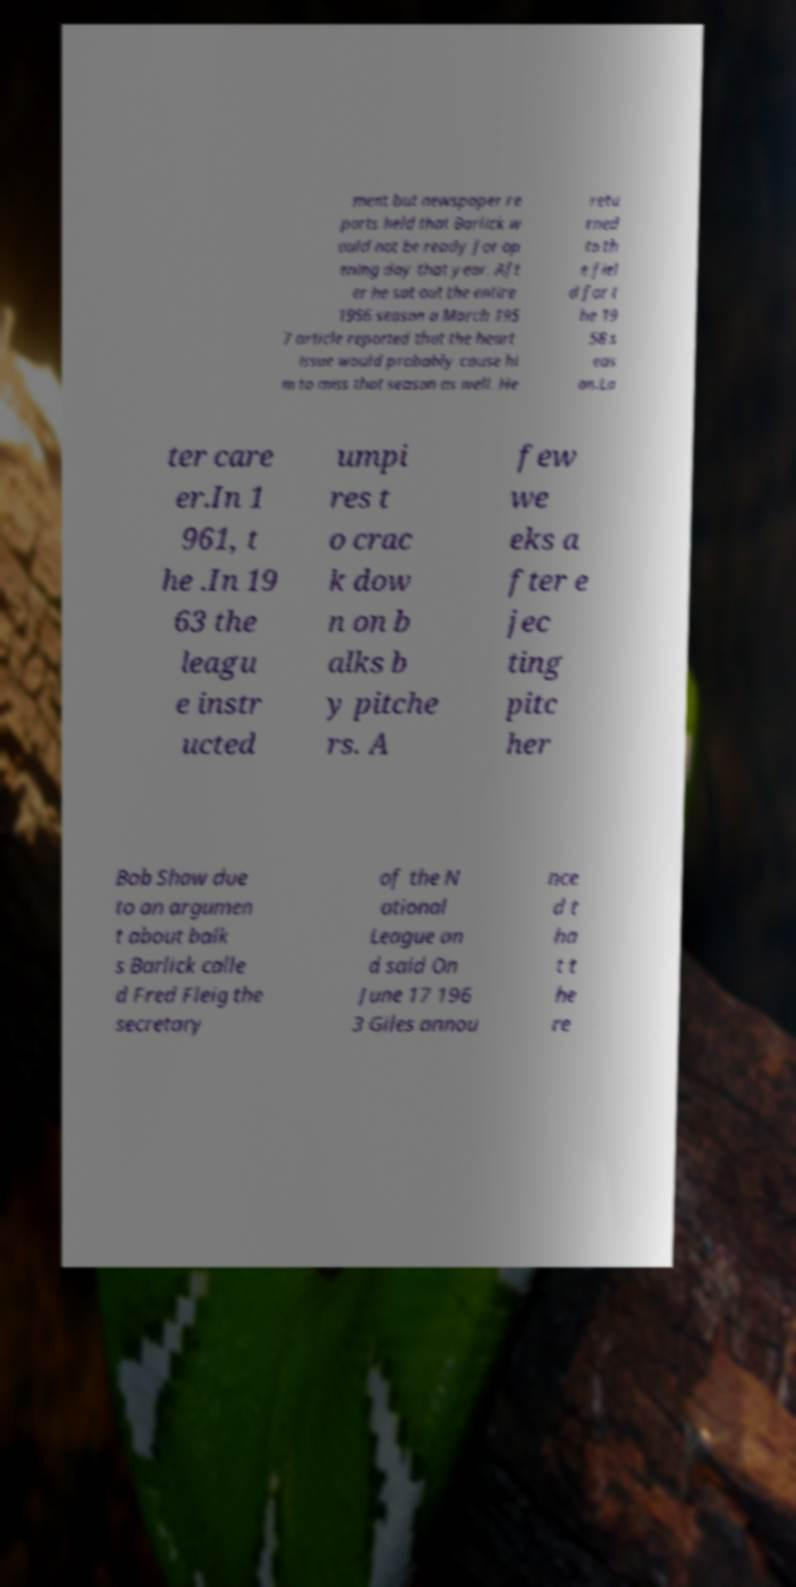For documentation purposes, I need the text within this image transcribed. Could you provide that? ment but newspaper re ports held that Barlick w ould not be ready for op ening day that year. Aft er he sat out the entire 1956 season a March 195 7 article reported that the heart issue would probably cause hi m to miss that season as well. He retu rned to th e fiel d for t he 19 58 s eas on.La ter care er.In 1 961, t he .In 19 63 the leagu e instr ucted umpi res t o crac k dow n on b alks b y pitche rs. A few we eks a fter e jec ting pitc her Bob Shaw due to an argumen t about balk s Barlick calle d Fred Fleig the secretary of the N ational League an d said On June 17 196 3 Giles annou nce d t ha t t he re 